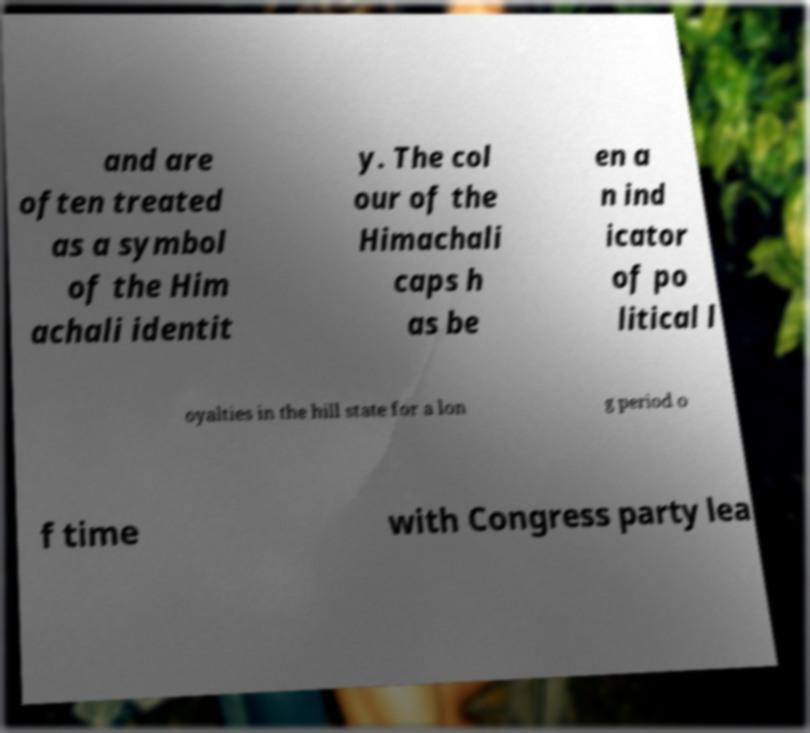Please read and relay the text visible in this image. What does it say? and are often treated as a symbol of the Him achali identit y. The col our of the Himachali caps h as be en a n ind icator of po litical l oyalties in the hill state for a lon g period o f time with Congress party lea 